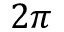<formula> <loc_0><loc_0><loc_500><loc_500>2 \pi</formula> 